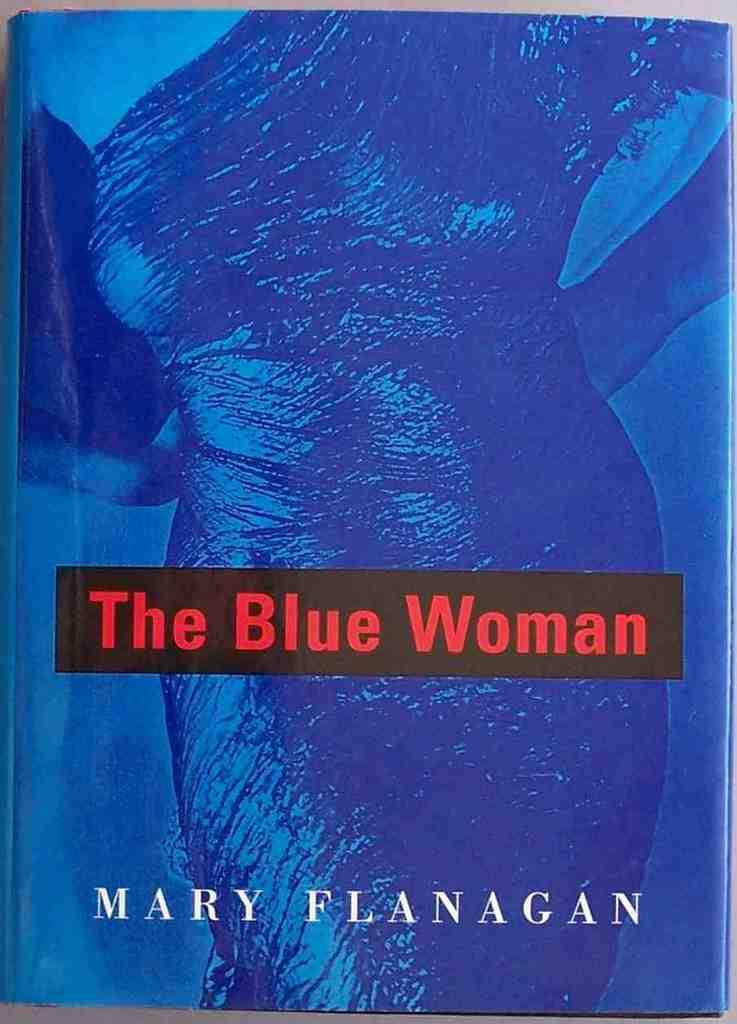<image>
Offer a succinct explanation of the picture presented. A blue book with a woman on the front titled The Blue Woman. 